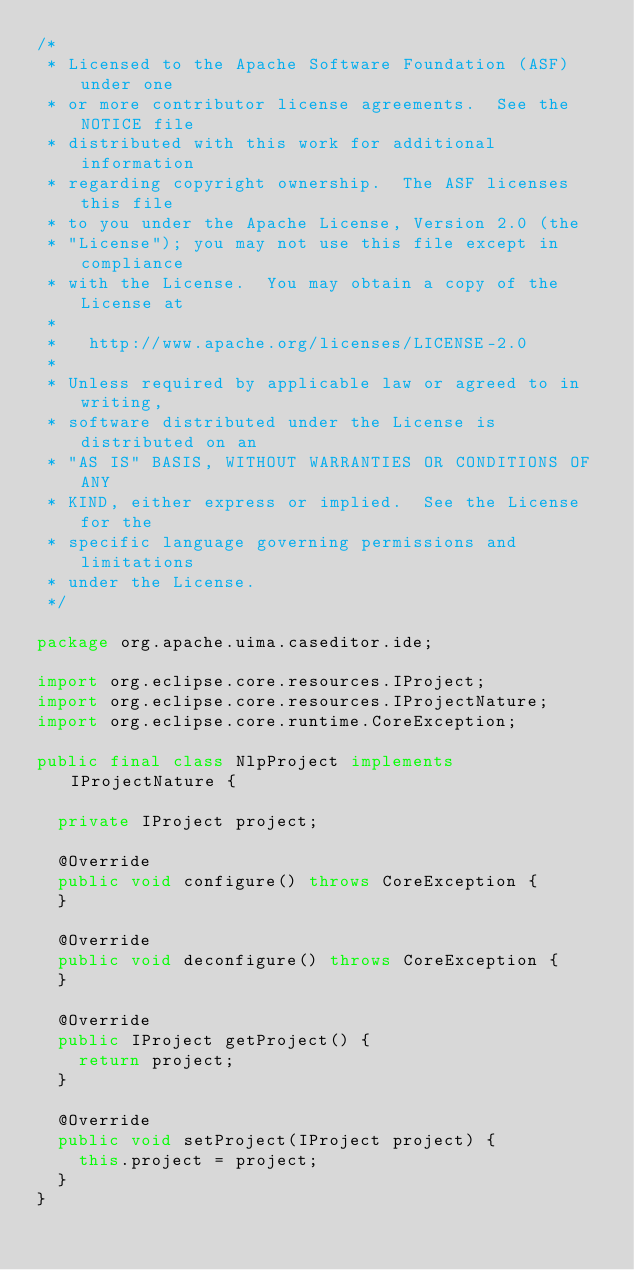Convert code to text. <code><loc_0><loc_0><loc_500><loc_500><_Java_>/*
 * Licensed to the Apache Software Foundation (ASF) under one
 * or more contributor license agreements.  See the NOTICE file
 * distributed with this work for additional information
 * regarding copyright ownership.  The ASF licenses this file
 * to you under the Apache License, Version 2.0 (the
 * "License"); you may not use this file except in compliance
 * with the License.  You may obtain a copy of the License at
 *
 *   http://www.apache.org/licenses/LICENSE-2.0
 *
 * Unless required by applicable law or agreed to in writing,
 * software distributed under the License is distributed on an
 * "AS IS" BASIS, WITHOUT WARRANTIES OR CONDITIONS OF ANY
 * KIND, either express or implied.  See the License for the
 * specific language governing permissions and limitations
 * under the License.
 */

package org.apache.uima.caseditor.ide;

import org.eclipse.core.resources.IProject;
import org.eclipse.core.resources.IProjectNature;
import org.eclipse.core.runtime.CoreException;

public final class NlpProject implements IProjectNature {

  private IProject project;
  
  @Override
  public void configure() throws CoreException {
  }
  
  @Override
  public void deconfigure() throws CoreException {
  }

  @Override
  public IProject getProject() {
    return project;
  }

  @Override
  public void setProject(IProject project) {
    this.project = project;
  }
}
</code> 